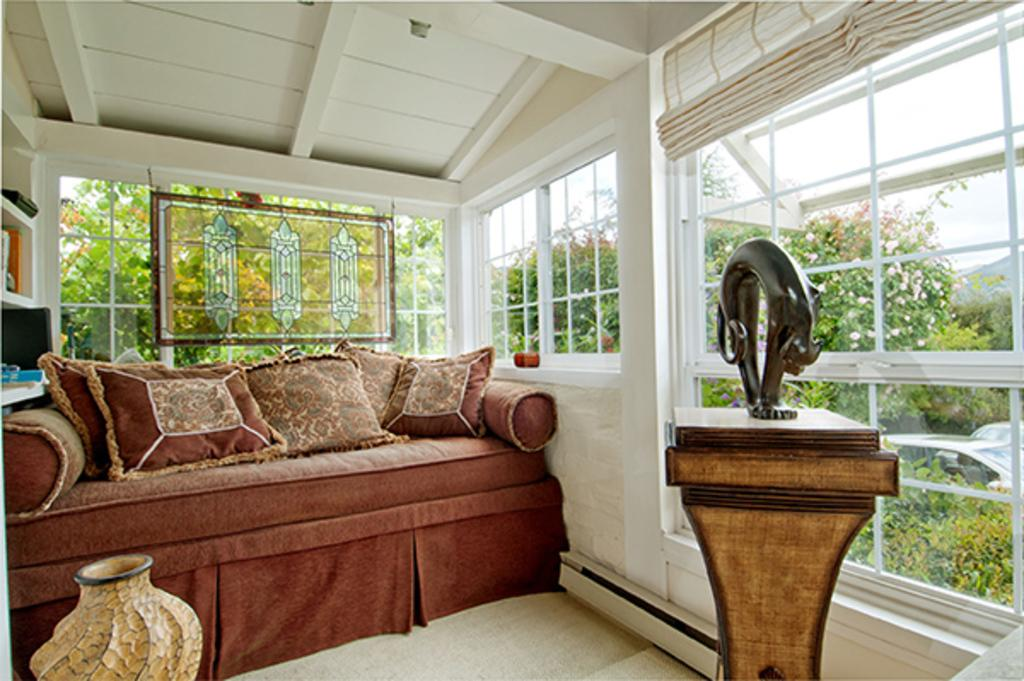What type of room is shown in the image? The image shows an interior view of a house. What piece of furniture is present in the room? There is a sofa bed in the image. What can be seen on the sofa bed? There are pillows in the image. What can be seen outside the room through a window? Trees are visible through a window in the image. What type of meal is being prepared in the image? There is no indication of a meal being prepared in the image; it shows a sofa bed, pillows, and a view of trees outside through a window. 